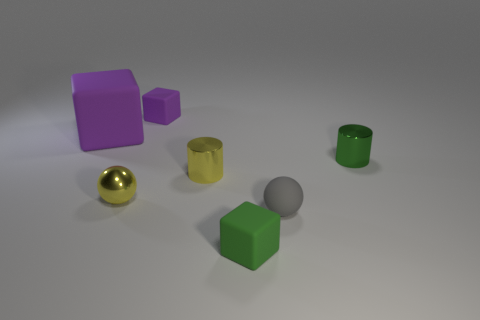Are there any small metallic balls of the same color as the big matte cube?
Make the answer very short. No. There is a metallic cylinder left of the matte cube in front of the ball that is on the right side of the tiny yellow shiny cylinder; what color is it?
Give a very brief answer. Yellow. Do the gray ball and the small green object that is behind the green matte object have the same material?
Your answer should be compact. No. What is the yellow sphere made of?
Your response must be concise. Metal. What material is the tiny cylinder that is the same color as the metallic sphere?
Your response must be concise. Metal. What number of other things are made of the same material as the green cylinder?
Ensure brevity in your answer.  2. The rubber object that is both right of the big purple matte thing and behind the tiny gray ball has what shape?
Keep it short and to the point. Cube. What color is the big object that is the same material as the tiny purple block?
Provide a short and direct response. Purple. Are there the same number of tiny yellow cylinders that are in front of the shiny ball and yellow objects?
Keep it short and to the point. No. There is a purple matte object that is the same size as the yellow cylinder; what shape is it?
Offer a terse response. Cube. 